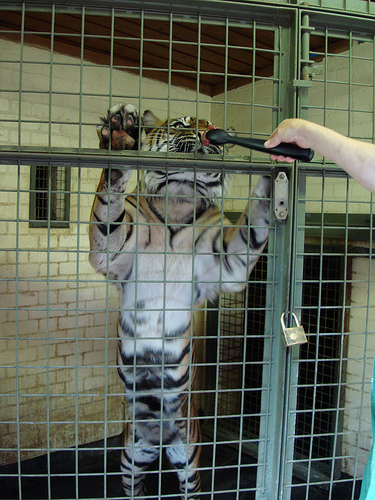<image>
Is there a paw on the door? Yes. Looking at the image, I can see the paw is positioned on top of the door, with the door providing support. Is the tiger behind the cage? Yes. From this viewpoint, the tiger is positioned behind the cage, with the cage partially or fully occluding the tiger. Is there a tiger behind the lock? Yes. From this viewpoint, the tiger is positioned behind the lock, with the lock partially or fully occluding the tiger. Is there a tiger in front of the spoon? No. The tiger is not in front of the spoon. The spatial positioning shows a different relationship between these objects. 